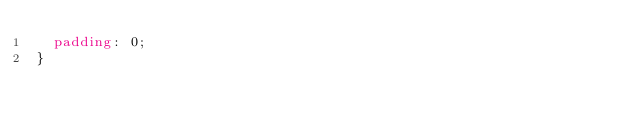<code> <loc_0><loc_0><loc_500><loc_500><_CSS_>  padding: 0;
}

</code> 